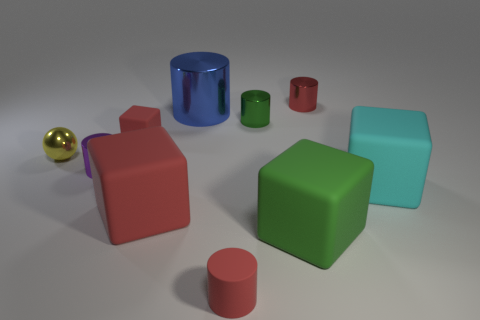Subtract all red cylinders. How many cylinders are left? 3 Subtract all large cylinders. How many cylinders are left? 4 Subtract all purple cylinders. Subtract all blue blocks. How many cylinders are left? 4 Subtract all cubes. How many objects are left? 6 Subtract all large cyan blocks. Subtract all big blue metal cylinders. How many objects are left? 8 Add 2 large cyan matte cubes. How many large cyan matte cubes are left? 3 Add 6 small brown spheres. How many small brown spheres exist? 6 Subtract 0 red balls. How many objects are left? 10 